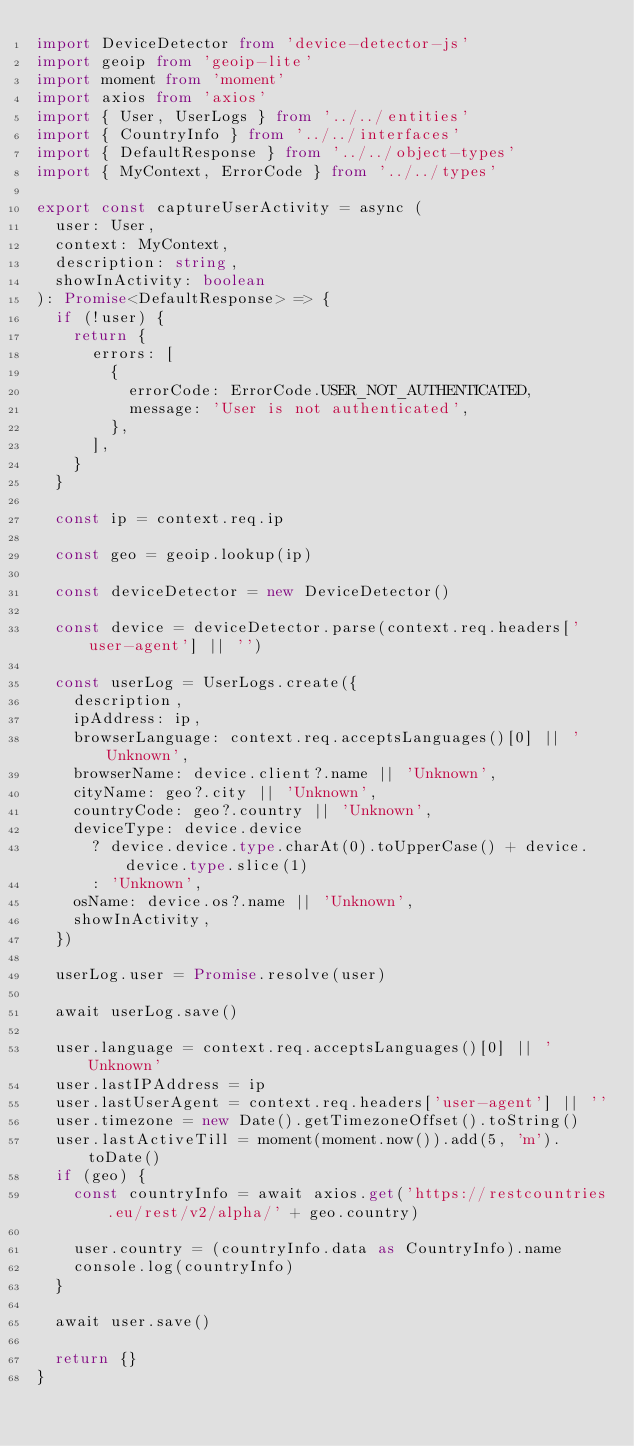Convert code to text. <code><loc_0><loc_0><loc_500><loc_500><_TypeScript_>import DeviceDetector from 'device-detector-js'
import geoip from 'geoip-lite'
import moment from 'moment'
import axios from 'axios'
import { User, UserLogs } from '../../entities'
import { CountryInfo } from '../../interfaces'
import { DefaultResponse } from '../../object-types'
import { MyContext, ErrorCode } from '../../types'

export const captureUserActivity = async (
  user: User,
  context: MyContext,
  description: string,
  showInActivity: boolean
): Promise<DefaultResponse> => {
  if (!user) {
    return {
      errors: [
        {
          errorCode: ErrorCode.USER_NOT_AUTHENTICATED,
          message: 'User is not authenticated',
        },
      ],
    }
  }

  const ip = context.req.ip

  const geo = geoip.lookup(ip)

  const deviceDetector = new DeviceDetector()

  const device = deviceDetector.parse(context.req.headers['user-agent'] || '')

  const userLog = UserLogs.create({
    description,
    ipAddress: ip,
    browserLanguage: context.req.acceptsLanguages()[0] || 'Unknown',
    browserName: device.client?.name || 'Unknown',
    cityName: geo?.city || 'Unknown',
    countryCode: geo?.country || 'Unknown',
    deviceType: device.device
      ? device.device.type.charAt(0).toUpperCase() + device.device.type.slice(1)
      : 'Unknown',
    osName: device.os?.name || 'Unknown',
    showInActivity,
  })

  userLog.user = Promise.resolve(user)

  await userLog.save()

  user.language = context.req.acceptsLanguages()[0] || 'Unknown'
  user.lastIPAddress = ip
  user.lastUserAgent = context.req.headers['user-agent'] || ''
  user.timezone = new Date().getTimezoneOffset().toString()
  user.lastActiveTill = moment(moment.now()).add(5, 'm').toDate()
  if (geo) {
    const countryInfo = await axios.get('https://restcountries.eu/rest/v2/alpha/' + geo.country)

    user.country = (countryInfo.data as CountryInfo).name
    console.log(countryInfo)
  }

  await user.save()

  return {}
}
</code> 